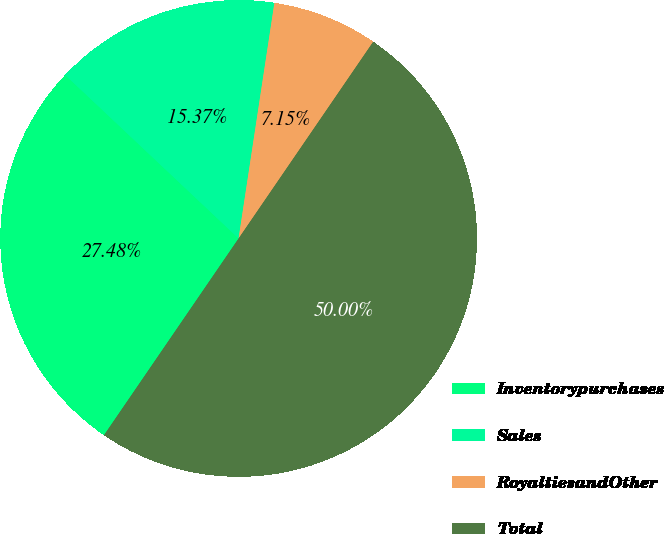<chart> <loc_0><loc_0><loc_500><loc_500><pie_chart><fcel>Inventorypurchases<fcel>Sales<fcel>RoyaltiesandOther<fcel>Total<nl><fcel>27.48%<fcel>15.37%<fcel>7.15%<fcel>50.0%<nl></chart> 